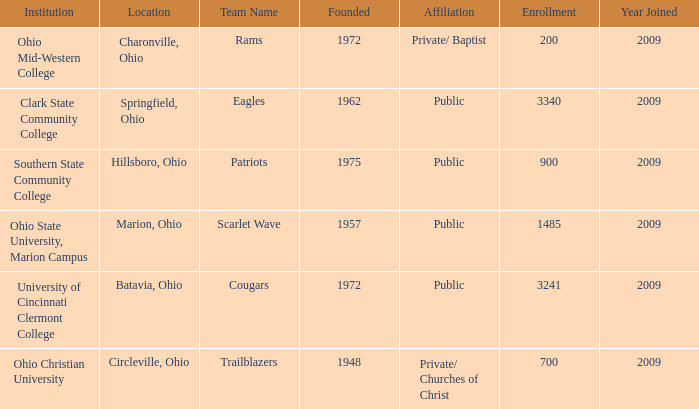What is the institution that was located is circleville, ohio? Ohio Christian University. 